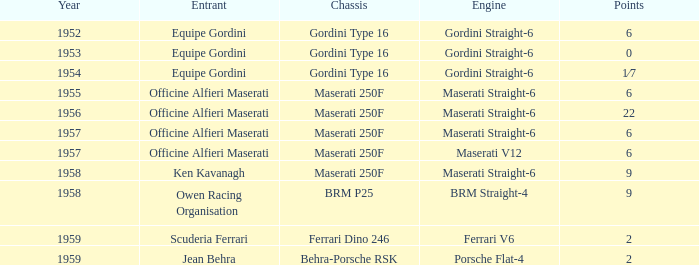What is the production year of a ferrari v6 engine? 1959.0. Can you parse all the data within this table? {'header': ['Year', 'Entrant', 'Chassis', 'Engine', 'Points'], 'rows': [['1952', 'Equipe Gordini', 'Gordini Type 16', 'Gordini Straight-6', '6'], ['1953', 'Equipe Gordini', 'Gordini Type 16', 'Gordini Straight-6', '0'], ['1954', 'Equipe Gordini', 'Gordini Type 16', 'Gordini Straight-6', '1⁄7'], ['1955', 'Officine Alfieri Maserati', 'Maserati 250F', 'Maserati Straight-6', '6'], ['1956', 'Officine Alfieri Maserati', 'Maserati 250F', 'Maserati Straight-6', '22'], ['1957', 'Officine Alfieri Maserati', 'Maserati 250F', 'Maserati Straight-6', '6'], ['1957', 'Officine Alfieri Maserati', 'Maserati 250F', 'Maserati V12', '6'], ['1958', 'Ken Kavanagh', 'Maserati 250F', 'Maserati Straight-6', '9'], ['1958', 'Owen Racing Organisation', 'BRM P25', 'BRM Straight-4', '9'], ['1959', 'Scuderia Ferrari', 'Ferrari Dino 246', 'Ferrari V6', '2'], ['1959', 'Jean Behra', 'Behra-Porsche RSK', 'Porsche Flat-4', '2']]} 